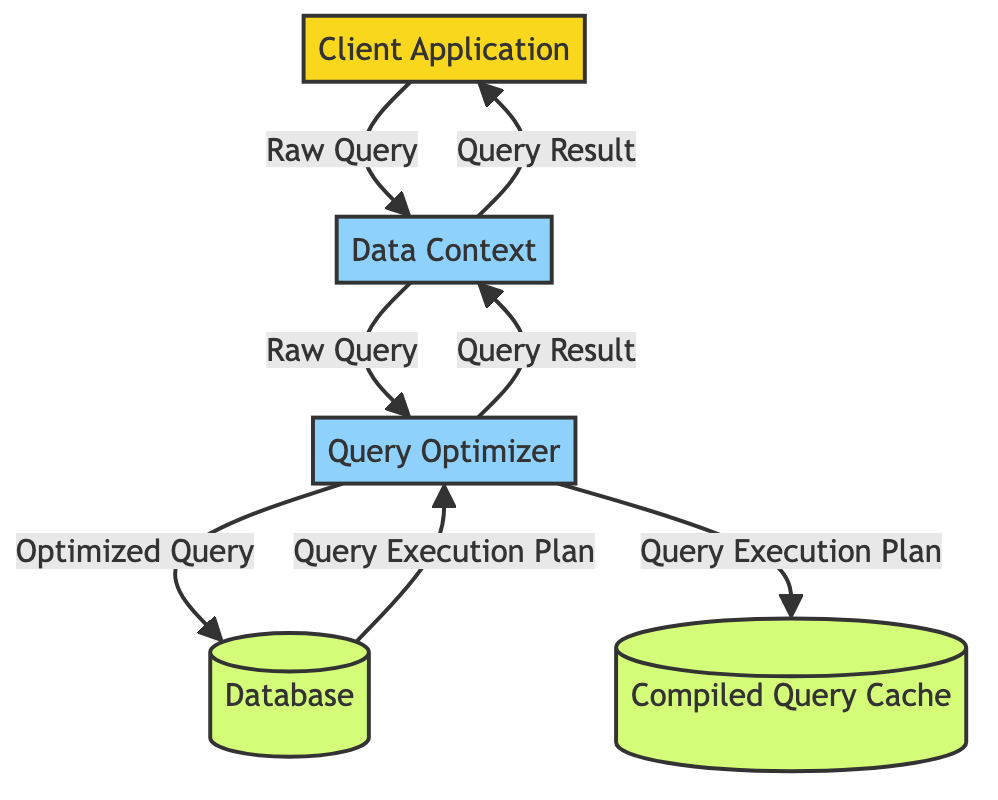What is the initial input to the Data Context? The initial input to the Data Context is provided by the Client Application, represented by the "Raw Query" data flow. This indicates that the Client Application sends a query to the Data Context for further processing.
Answer: Raw Query How many processes are present in the diagram? The processes in the diagram include the Data Context and Query Optimizer. By counting these nodes, we find there are two processes connected by the data flows.
Answer: 2 What data flows from the Query Optimizer to the Database? The Query Optimizer optimizes the query and then sends the optimized version to the Database, as indicated by the connection labeled "Optimized Query."
Answer: Optimized Query What is stored in the Compiled Query Cache? The Compiled Query Cache stores the "Query Execution Plan" derived from the Query Optimizer before this data is utilized again. This shows that the execution plan of the queries that have been optimized is cached for future use.
Answer: Query Execution Plan What is the final output of the process flow? The final output after processing through the Data Context is the "Query Result," which is returned to the Client Application. This indicates the result of the executed query back to the initial requester.
Answer: Query Result How many external entities are in the diagram? There is only one external entity, which is the Client Application, providing the entry point for the data into the system before going through the Data Context and Query Optimizer.
Answer: 1 What does the Database send back to the Query Optimizer? The Database sends back a "Query Execution Plan" to the Query Optimizer after the optimized query is sent. This step is essential as it provides feedback on how the query will be executed.
Answer: Query Execution Plan Which component handles query optimization in the flow? The component responsible for query optimization in the flow is the "Query Optimizer," which processes the raw query and generates an optimized version to be sent to the Database.
Answer: Query Optimizer What is the role of the Data Context? The Data Context serves as the intermediary between the Client Application and the Query Optimizer, receiving the initial raw query and returning the final query result back to the Client Application after optimization.
Answer: Process intermediary 